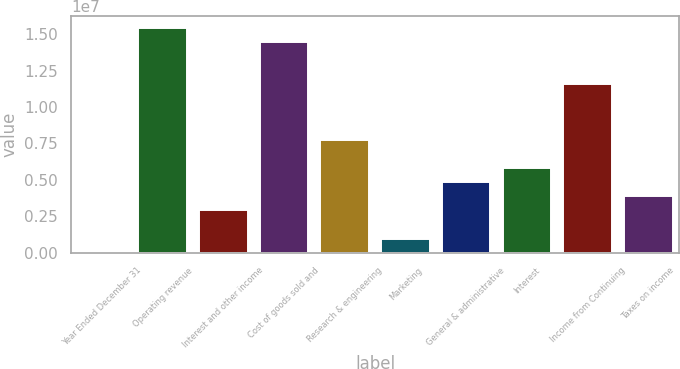Convert chart. <chart><loc_0><loc_0><loc_500><loc_500><bar_chart><fcel>Year Ended December 31<fcel>Operating revenue<fcel>Interest and other income<fcel>Cost of goods sold and<fcel>Research & engineering<fcel>Marketing<fcel>General & administrative<fcel>Interest<fcel>Income from Continuing<fcel>Taxes on income<nl><fcel>2002<fcel>1.54506e+07<fcel>2.89862e+06<fcel>1.44851e+07<fcel>7.72633e+06<fcel>967542<fcel>4.8297e+06<fcel>5.79524e+06<fcel>1.15885e+07<fcel>3.86416e+06<nl></chart> 